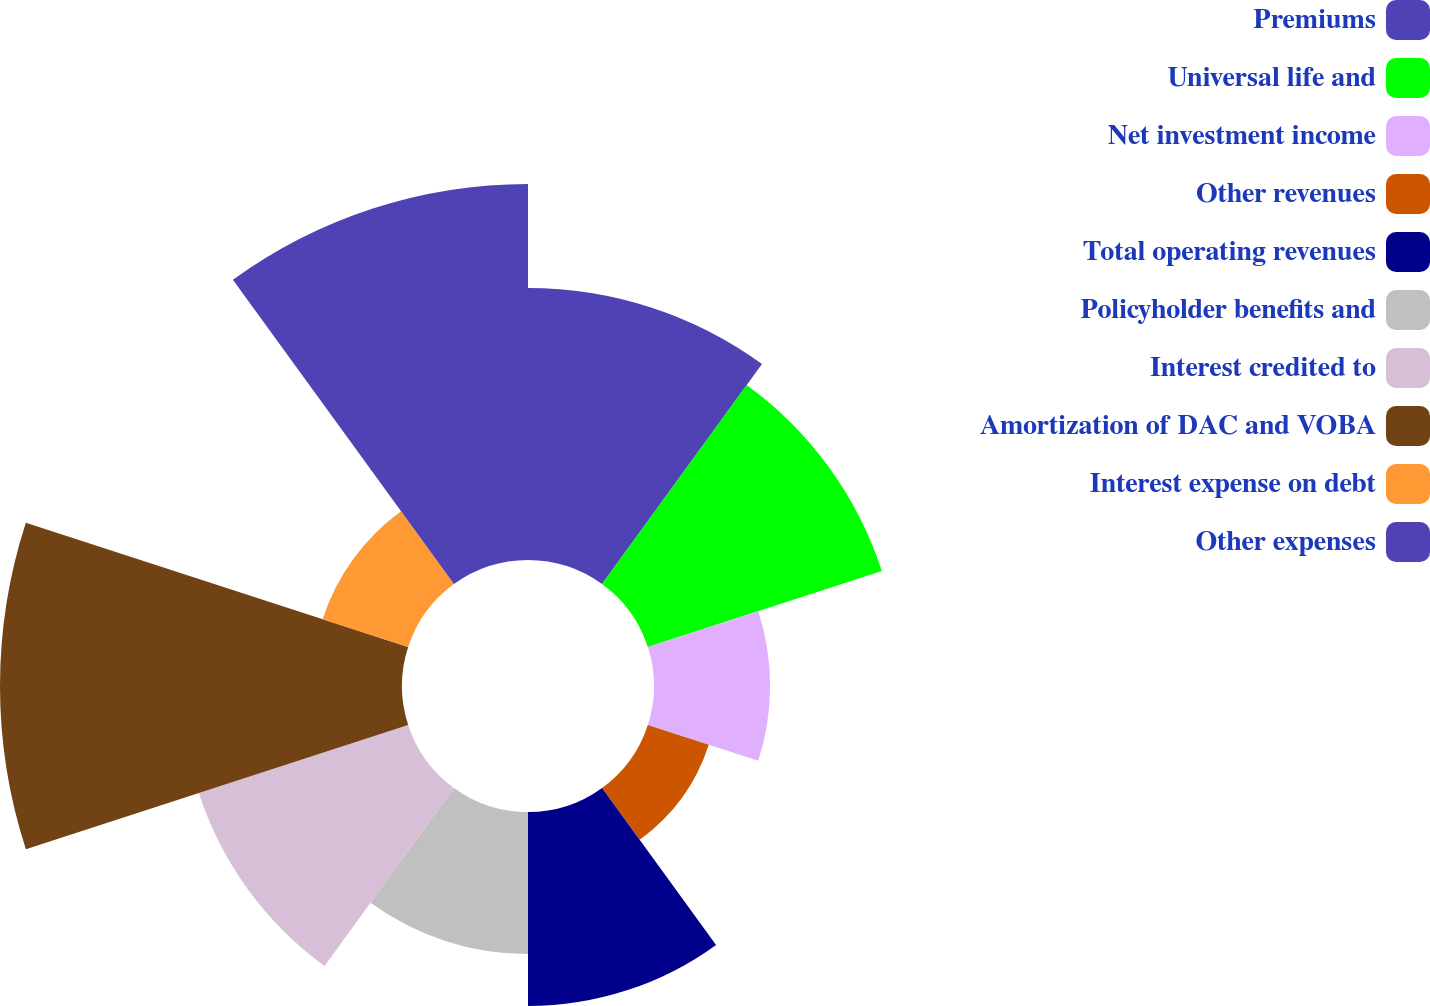Convert chart to OTSL. <chart><loc_0><loc_0><loc_500><loc_500><pie_chart><fcel>Premiums<fcel>Universal life and<fcel>Net investment income<fcel>Other revenues<fcel>Total operating revenues<fcel>Policyholder benefits and<fcel>Interest credited to<fcel>Amortization of DAC and VOBA<fcel>Interest expense on debt<fcel>Other expenses<nl><fcel>12.82%<fcel>11.59%<fcel>5.47%<fcel>3.02%<fcel>9.14%<fcel>6.69%<fcel>10.37%<fcel>18.94%<fcel>4.24%<fcel>17.72%<nl></chart> 